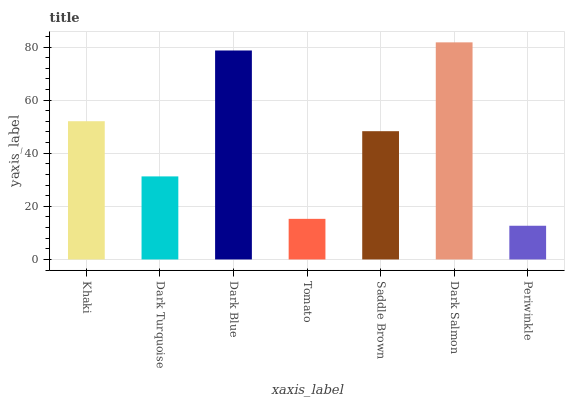Is Periwinkle the minimum?
Answer yes or no. Yes. Is Dark Salmon the maximum?
Answer yes or no. Yes. Is Dark Turquoise the minimum?
Answer yes or no. No. Is Dark Turquoise the maximum?
Answer yes or no. No. Is Khaki greater than Dark Turquoise?
Answer yes or no. Yes. Is Dark Turquoise less than Khaki?
Answer yes or no. Yes. Is Dark Turquoise greater than Khaki?
Answer yes or no. No. Is Khaki less than Dark Turquoise?
Answer yes or no. No. Is Saddle Brown the high median?
Answer yes or no. Yes. Is Saddle Brown the low median?
Answer yes or no. Yes. Is Khaki the high median?
Answer yes or no. No. Is Periwinkle the low median?
Answer yes or no. No. 